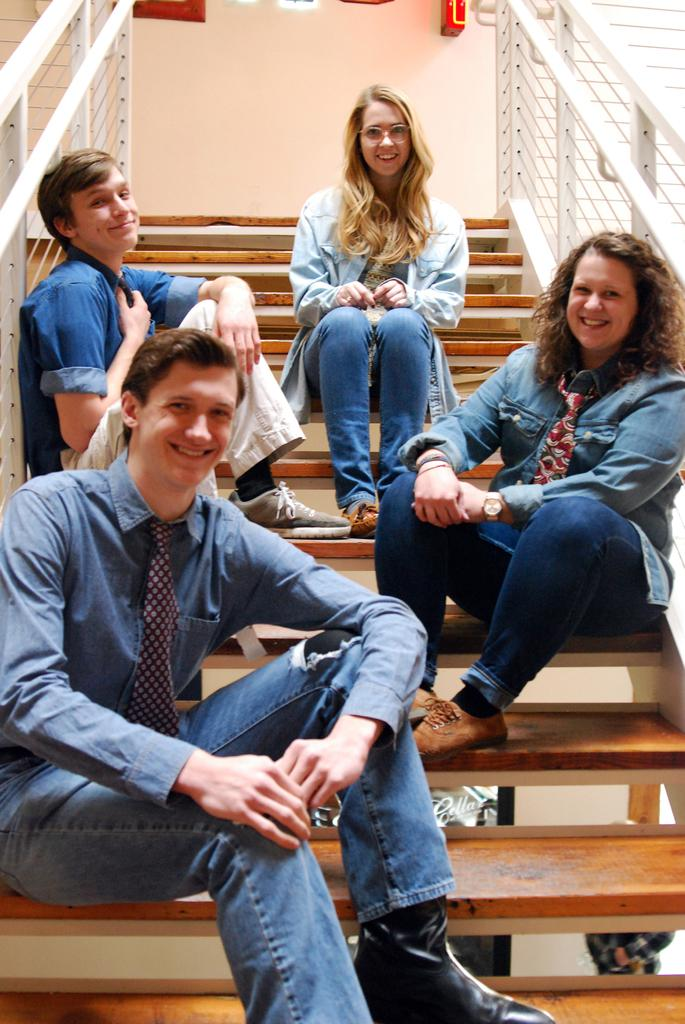How many people are in the image? There are two women and two men in the image. What are the individuals doing in the image? The individuals are sitting on the stairs and smiling. What material are the stairs made of? The stairs are made of wood. What else can be seen in the image besides the people and stairs? There is a wall in the image. What type of oil is being used to increase the size of the stairs in the image? There is no oil or increase in size of the stairs mentioned in the image. The stairs are made of wood and are not changing in size. 